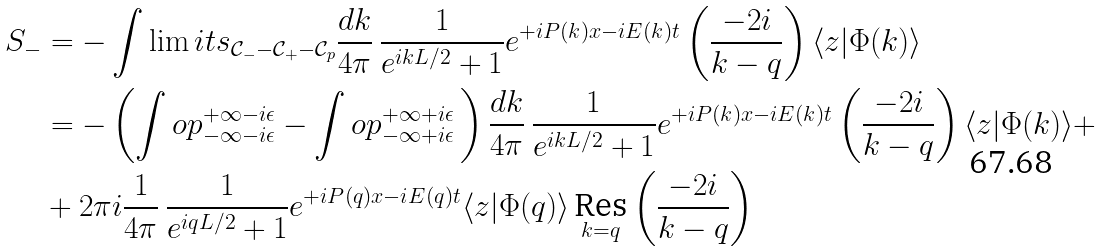Convert formula to latex. <formula><loc_0><loc_0><loc_500><loc_500>S _ { - } & = - \int \lim i t s _ { \mathcal { C } _ { - } - \mathcal { C } _ { + } - \mathcal { C } _ { p } } \frac { d k } { 4 \pi } \, \frac { 1 } { e ^ { i k L / 2 } + 1 } e ^ { + i P ( k ) x - i E ( k ) t } \left ( \frac { - 2 i } { k - q } \right ) \langle z | \Phi ( k ) \rangle \\ & = - \left ( \int o p _ { - \infty - i \epsilon } ^ { + \infty - i \epsilon } - \int o p _ { - \infty + i \epsilon } ^ { + \infty + i \epsilon } \, \right ) \frac { d k } { 4 \pi } \, \frac { 1 } { e ^ { i k L / 2 } + 1 } e ^ { + i P ( k ) x - i E ( k ) t } \left ( \frac { - 2 i } { k - q } \right ) \langle z | \Phi ( k ) \rangle + \\ & + 2 \pi i \frac { 1 } { 4 \pi } \, \frac { 1 } { e ^ { i q L / 2 } + 1 } e ^ { + i P ( q ) x - i E ( q ) t } \langle z | \Phi ( q ) \rangle \, \underset { k = q } { \text {Res} } \left ( \frac { - 2 i } { k - q } \right )</formula> 